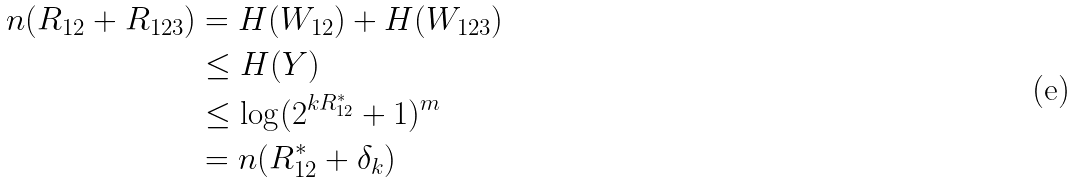Convert formula to latex. <formula><loc_0><loc_0><loc_500><loc_500>n ( R _ { 1 2 } + R _ { 1 2 3 } ) & = H ( { W } _ { 1 2 } ) + H ( { W } _ { 1 2 3 } ) \\ & \leq H ( { Y } ) \\ & \leq \log ( 2 ^ { k R _ { 1 2 } ^ { * } } + 1 ) ^ { m } \\ & = n ( R _ { 1 2 } ^ { * } + \delta _ { k } )</formula> 